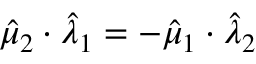<formula> <loc_0><loc_0><loc_500><loc_500>\hat { \mu } _ { 2 } \cdot \hat { \lambda } _ { 1 } = - \hat { \mu } _ { 1 } \cdot \hat { \lambda } _ { 2 }</formula> 